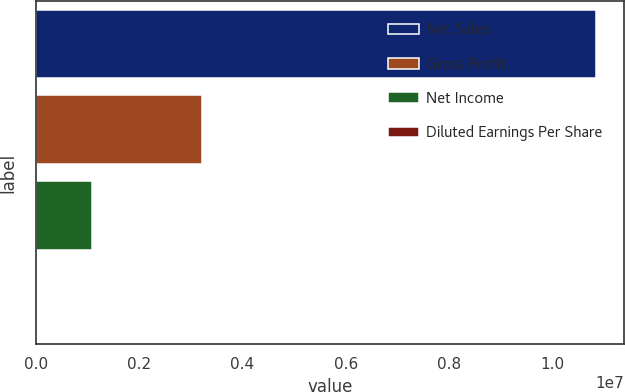Convert chart to OTSL. <chart><loc_0><loc_0><loc_500><loc_500><bar_chart><fcel>Net Sales<fcel>Gross Profit<fcel>Net Income<fcel>Diluted Earnings Per Share<nl><fcel>1.08432e+07<fcel>3.21722e+06<fcel>1.08432e+06<fcel>2.98<nl></chart> 